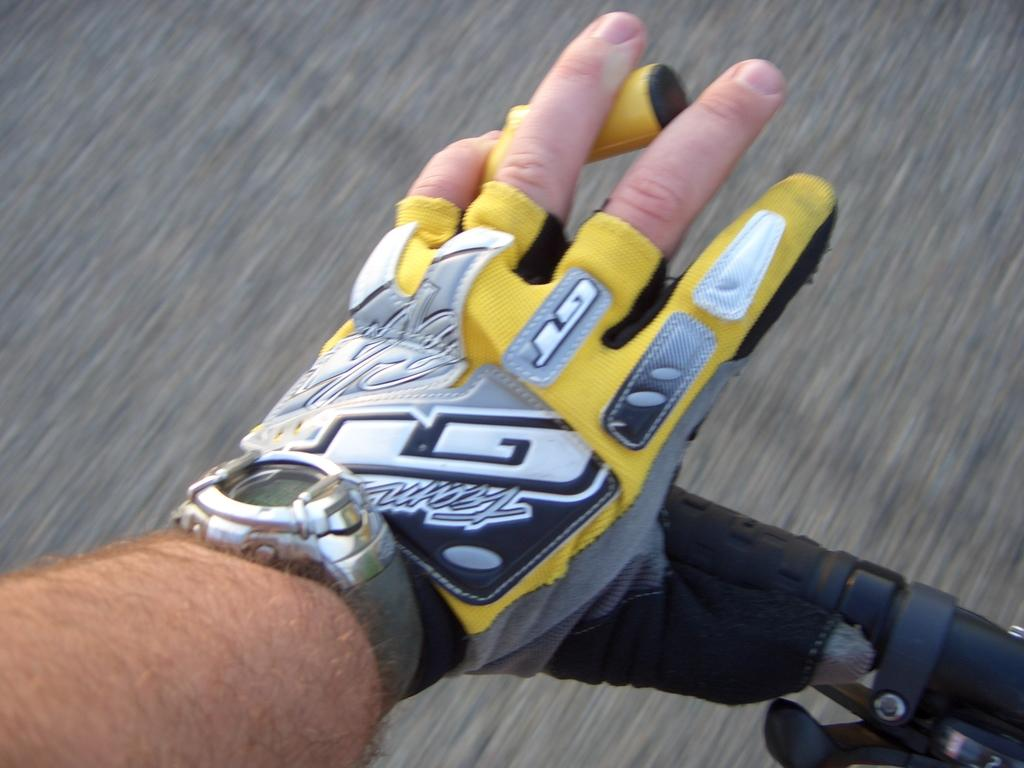What part of a person's body is visible in the image? There is a person's hand in the image. What is the person holding in the image? The person is holding the handle of something. What accessory is on the hand? There is a watch on the hand. What type of clothing is the person wearing on their hand? The person is wearing a glove. How many kittens are playing in space in the image? There are no kittens or space present in the image; it features a person's hand holding something while wearing a glove and a watch. 